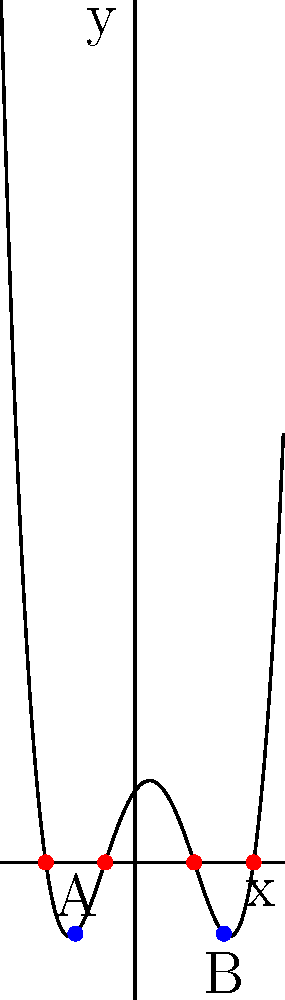In the polynomial graph above, which represents the journey in Green Book, the turning points A and B correspond to crucial moments in the film. If point A represents the scene where Tony and Dr. Shirley start to understand each other better, and point B represents their final performance together, what do the x-intercepts between A and B signify in the context of the movie? Let's analyze this step-by-step:

1. The polynomial graph represents the journey of Tony and Dr. Shirley in Green Book.

2. The turning points (A and B) represent crucial moments in the film:
   - Point A: Tony and Dr. Shirley start to understand each other better
   - Point B: Their final performance together

3. Between points A and B, there are two x-intercepts (where the graph crosses the x-axis).

4. In the context of a journey or story, x-intercepts often represent significant events or turning points.

5. In Green Book, between the moment Tony and Dr. Shirley start to understand each other and their final performance, there are two major events:
   - The incident at the segregated restaurant where Dr. Shirley is not allowed to dine
   - The bar scene where Dr. Shirley stands up for himself and Tony supports him

6. These two events are significant in developing the characters' relationship and advancing the plot, much like how the x-intercepts are significant points in the polynomial function.

Therefore, the x-intercepts between A and B likely signify these two pivotal events in the movie that occur between the initial understanding and the final performance.
Answer: The segregated restaurant incident and the bar scene 